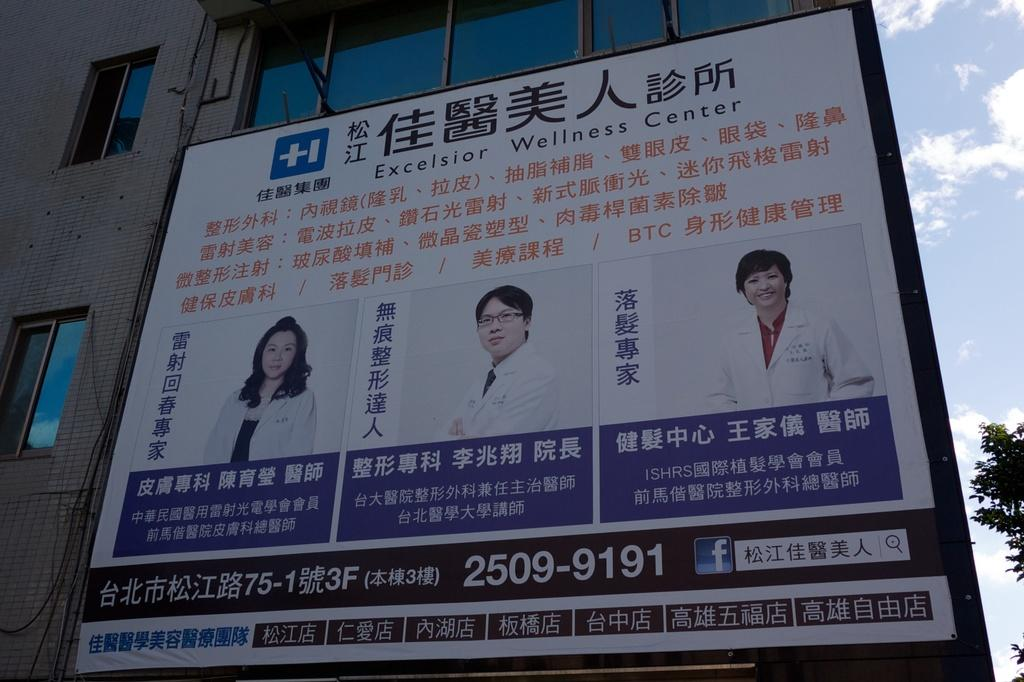<image>
Describe the image concisely. A sign in foreign characters that shows the number 2509-9191. 